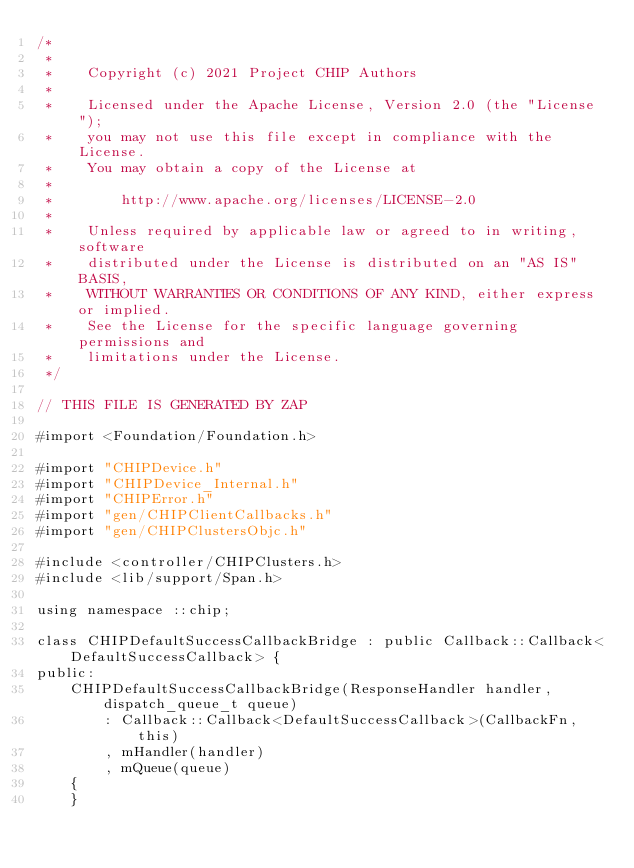<code> <loc_0><loc_0><loc_500><loc_500><_ObjectiveC_>/*
 *
 *    Copyright (c) 2021 Project CHIP Authors
 *
 *    Licensed under the Apache License, Version 2.0 (the "License");
 *    you may not use this file except in compliance with the License.
 *    You may obtain a copy of the License at
 *
 *        http://www.apache.org/licenses/LICENSE-2.0
 *
 *    Unless required by applicable law or agreed to in writing, software
 *    distributed under the License is distributed on an "AS IS" BASIS,
 *    WITHOUT WARRANTIES OR CONDITIONS OF ANY KIND, either express or implied.
 *    See the License for the specific language governing permissions and
 *    limitations under the License.
 */

// THIS FILE IS GENERATED BY ZAP

#import <Foundation/Foundation.h>

#import "CHIPDevice.h"
#import "CHIPDevice_Internal.h"
#import "CHIPError.h"
#import "gen/CHIPClientCallbacks.h"
#import "gen/CHIPClustersObjc.h"

#include <controller/CHIPClusters.h>
#include <lib/support/Span.h>

using namespace ::chip;

class CHIPDefaultSuccessCallbackBridge : public Callback::Callback<DefaultSuccessCallback> {
public:
    CHIPDefaultSuccessCallbackBridge(ResponseHandler handler, dispatch_queue_t queue)
        : Callback::Callback<DefaultSuccessCallback>(CallbackFn, this)
        , mHandler(handler)
        , mQueue(queue)
    {
    }
</code> 